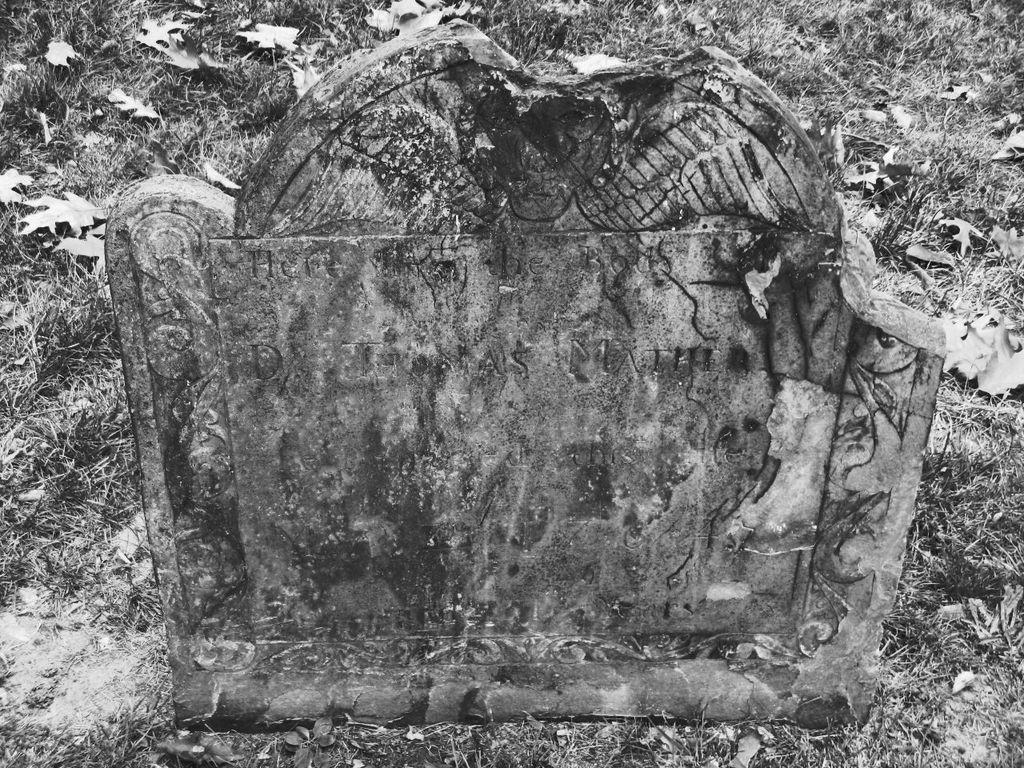What is the main object in the image? There is a rock in the image. What else can be seen on the ground in the image? There are dried twigs on the ground in the image. Where are the books stored in the image? There are no books present in the image. What type of stove can be seen in the image? There is no stove present in the image. 